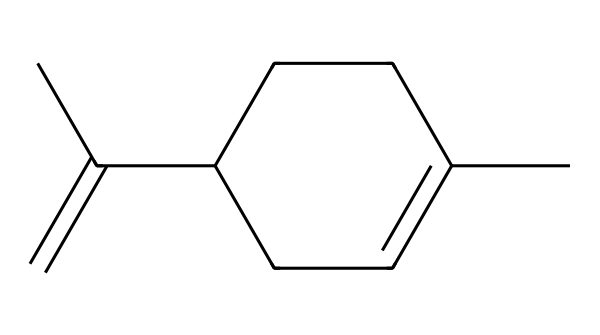What is the molecular formula of limonene? To find the molecular formula, count the number of carbon (C), hydrogen (H), and other atoms in the structure given by the SMILES. The structure contains 10 carbon atoms and 16 hydrogen atoms, resulting in the formula C10H16.
Answer: C10H16 How many chiral centers are present in limonene? A chiral center is typically a carbon atom bonded to four different groups. In the structure of limonene, there is one carbon atom (the one connected to the two different branches) that meets these criteria, indicating one chiral center.
Answer: 1 Is limonene an alkene? To classify limonene, we look for the presence of double bonds. In the SMILES representation, there are carbon atoms forming a double bond, which characterizes it as an alkene.
Answer: yes What functional group is associated with limonene? Limonene contains a double bond characteristic of alkenes, and it may have a cycloalkane or hydrocarbon group. Given that it is not a typical alcohol, carboxylic acid, or ketone, it lacks those functional groups.
Answer: alkene Does limonene exhibit optical activity? Limonene, due to its chiral center, means it can exist as enantiomers, leading to optical activity, which means it can rotate plane-polarized light.
Answer: yes Which configuration does limonene mainly adopt? Limonene is predominantly found in the S configuration, which refers to its specific three-dimensional arrangement at the chiral center.
Answer: S configuration 